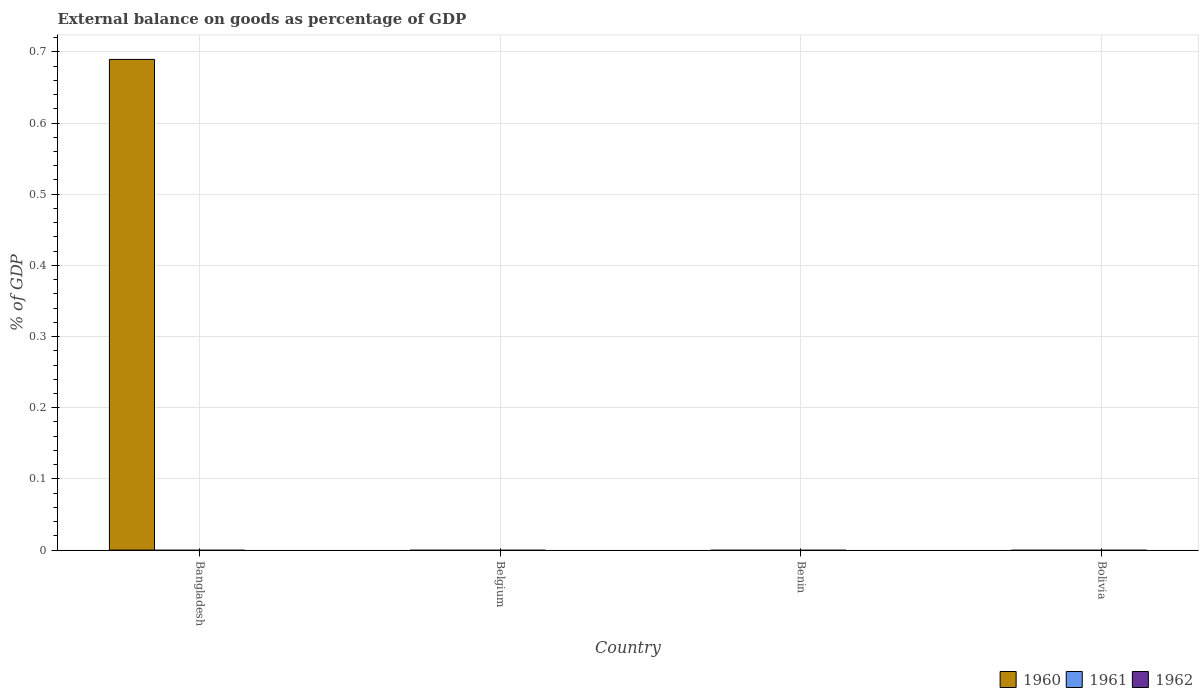How many different coloured bars are there?
Make the answer very short. 1. What is the label of the 2nd group of bars from the left?
Make the answer very short. Belgium. In how many cases, is the number of bars for a given country not equal to the number of legend labels?
Offer a very short reply. 4. Across all countries, what is the maximum external balance on goods as percentage of GDP in 1960?
Provide a succinct answer. 0.69. Across all countries, what is the minimum external balance on goods as percentage of GDP in 1962?
Keep it short and to the point. 0. In which country was the external balance on goods as percentage of GDP in 1960 maximum?
Offer a terse response. Bangladesh. What is the total external balance on goods as percentage of GDP in 1962 in the graph?
Keep it short and to the point. 0. What is the difference between the external balance on goods as percentage of GDP in 1961 in Belgium and the external balance on goods as percentage of GDP in 1960 in Bolivia?
Your answer should be compact. 0. What is the average external balance on goods as percentage of GDP in 1961 per country?
Your response must be concise. 0. What is the difference between the highest and the lowest external balance on goods as percentage of GDP in 1960?
Provide a succinct answer. 0.69. In how many countries, is the external balance on goods as percentage of GDP in 1961 greater than the average external balance on goods as percentage of GDP in 1961 taken over all countries?
Ensure brevity in your answer.  0. How many bars are there?
Make the answer very short. 1. Are all the bars in the graph horizontal?
Your answer should be very brief. No. Does the graph contain grids?
Make the answer very short. Yes. Where does the legend appear in the graph?
Offer a very short reply. Bottom right. How many legend labels are there?
Your answer should be very brief. 3. What is the title of the graph?
Your answer should be compact. External balance on goods as percentage of GDP. Does "1986" appear as one of the legend labels in the graph?
Your answer should be compact. No. What is the label or title of the Y-axis?
Make the answer very short. % of GDP. What is the % of GDP in 1960 in Bangladesh?
Offer a very short reply. 0.69. What is the % of GDP of 1961 in Bangladesh?
Your answer should be very brief. 0. What is the % of GDP in 1960 in Belgium?
Your answer should be very brief. 0. What is the % of GDP in 1961 in Benin?
Keep it short and to the point. 0. What is the % of GDP in 1960 in Bolivia?
Your response must be concise. 0. What is the % of GDP in 1961 in Bolivia?
Your response must be concise. 0. What is the % of GDP of 1962 in Bolivia?
Give a very brief answer. 0. Across all countries, what is the maximum % of GDP of 1960?
Offer a terse response. 0.69. What is the total % of GDP of 1960 in the graph?
Provide a short and direct response. 0.69. What is the average % of GDP in 1960 per country?
Your answer should be very brief. 0.17. What is the average % of GDP of 1961 per country?
Offer a very short reply. 0. What is the average % of GDP in 1962 per country?
Offer a very short reply. 0. What is the difference between the highest and the lowest % of GDP of 1960?
Make the answer very short. 0.69. 